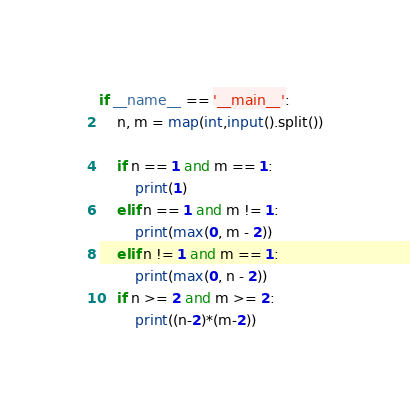Convert code to text. <code><loc_0><loc_0><loc_500><loc_500><_Python_>if __name__ == '__main__':
    n, m = map(int,input().split())

    if n == 1 and m == 1:
        print(1)
    elif n == 1 and m != 1:
        print(max(0, m - 2))
    elif n != 1 and m == 1:
        print(max(0, n - 2))
    if n >= 2 and m >= 2:
        print((n-2)*(m-2))
</code> 